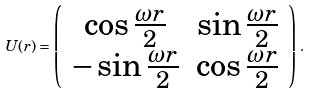Convert formula to latex. <formula><loc_0><loc_0><loc_500><loc_500>U ( r ) = \left ( \begin{array} { c c } \cos \frac { \omega r } { 2 } & \sin \frac { \omega r } { 2 } \\ - \sin \frac { \omega r } { 2 } & \cos \frac { \omega r } { 2 } \end{array} \right ) \, .</formula> 